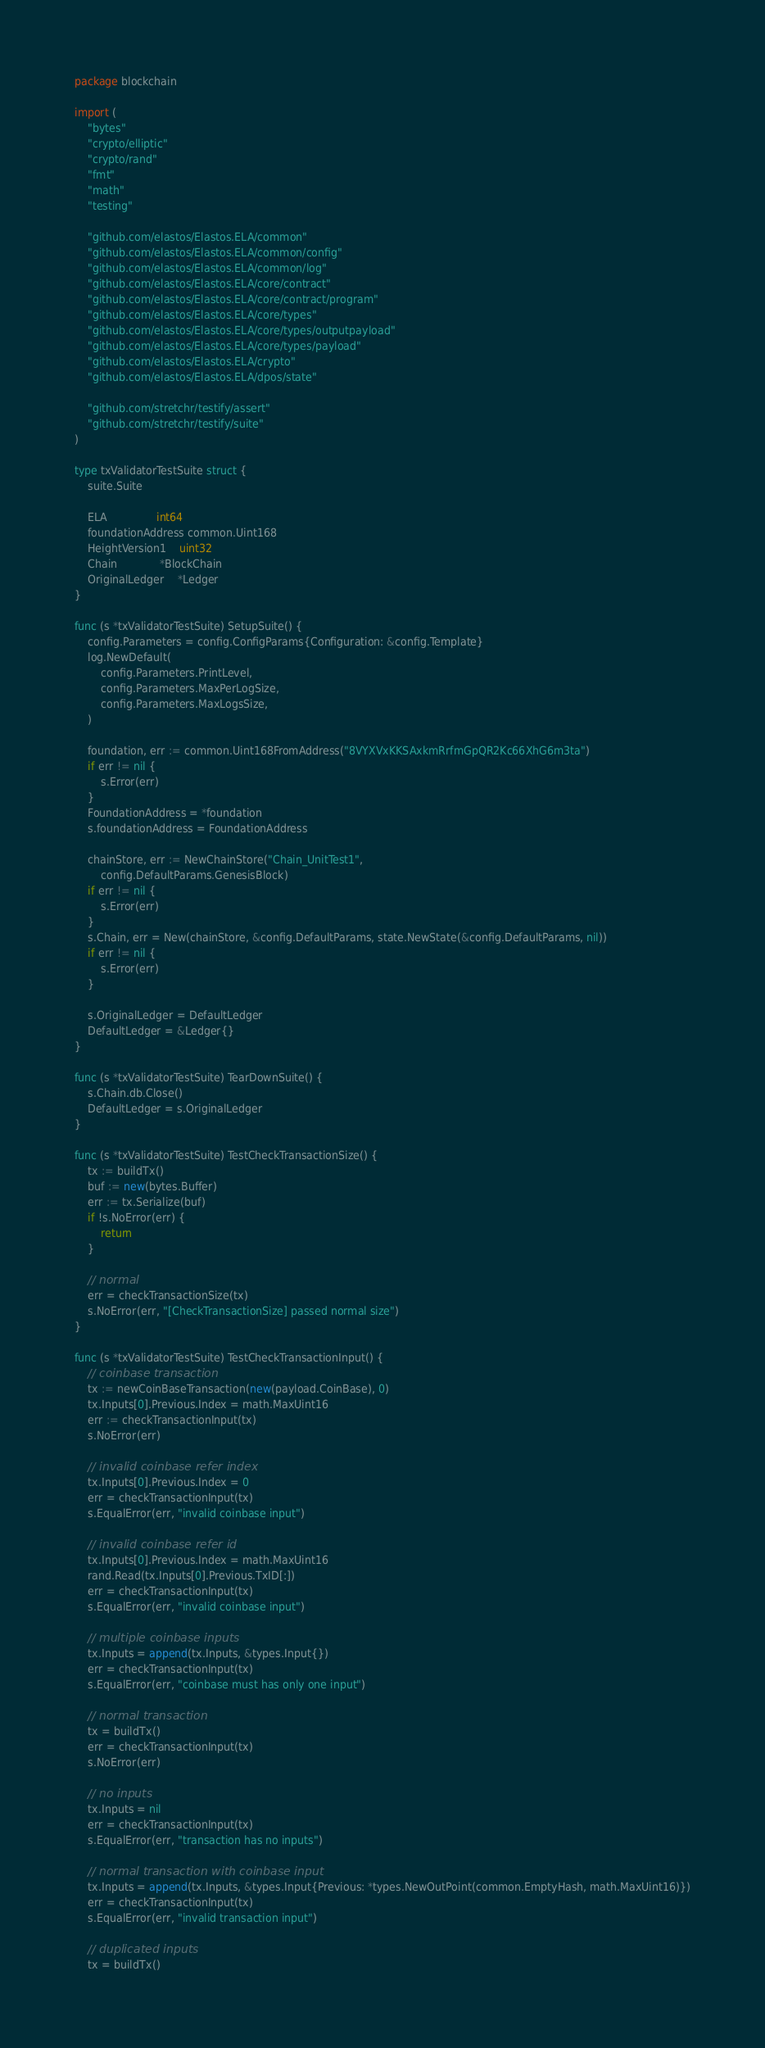Convert code to text. <code><loc_0><loc_0><loc_500><loc_500><_Go_>package blockchain

import (
	"bytes"
	"crypto/elliptic"
	"crypto/rand"
	"fmt"
	"math"
	"testing"

	"github.com/elastos/Elastos.ELA/common"
	"github.com/elastos/Elastos.ELA/common/config"
	"github.com/elastos/Elastos.ELA/common/log"
	"github.com/elastos/Elastos.ELA/core/contract"
	"github.com/elastos/Elastos.ELA/core/contract/program"
	"github.com/elastos/Elastos.ELA/core/types"
	"github.com/elastos/Elastos.ELA/core/types/outputpayload"
	"github.com/elastos/Elastos.ELA/core/types/payload"
	"github.com/elastos/Elastos.ELA/crypto"
	"github.com/elastos/Elastos.ELA/dpos/state"

	"github.com/stretchr/testify/assert"
	"github.com/stretchr/testify/suite"
)

type txValidatorTestSuite struct {
	suite.Suite

	ELA               int64
	foundationAddress common.Uint168
	HeightVersion1    uint32
	Chain             *BlockChain
	OriginalLedger    *Ledger
}

func (s *txValidatorTestSuite) SetupSuite() {
	config.Parameters = config.ConfigParams{Configuration: &config.Template}
	log.NewDefault(
		config.Parameters.PrintLevel,
		config.Parameters.MaxPerLogSize,
		config.Parameters.MaxLogsSize,
	)

	foundation, err := common.Uint168FromAddress("8VYXVxKKSAxkmRrfmGpQR2Kc66XhG6m3ta")
	if err != nil {
		s.Error(err)
	}
	FoundationAddress = *foundation
	s.foundationAddress = FoundationAddress

	chainStore, err := NewChainStore("Chain_UnitTest1",
		config.DefaultParams.GenesisBlock)
	if err != nil {
		s.Error(err)
	}
	s.Chain, err = New(chainStore, &config.DefaultParams, state.NewState(&config.DefaultParams, nil))
	if err != nil {
		s.Error(err)
	}

	s.OriginalLedger = DefaultLedger
	DefaultLedger = &Ledger{}
}

func (s *txValidatorTestSuite) TearDownSuite() {
	s.Chain.db.Close()
	DefaultLedger = s.OriginalLedger
}

func (s *txValidatorTestSuite) TestCheckTransactionSize() {
	tx := buildTx()
	buf := new(bytes.Buffer)
	err := tx.Serialize(buf)
	if !s.NoError(err) {
		return
	}

	// normal
	err = checkTransactionSize(tx)
	s.NoError(err, "[CheckTransactionSize] passed normal size")
}

func (s *txValidatorTestSuite) TestCheckTransactionInput() {
	// coinbase transaction
	tx := newCoinBaseTransaction(new(payload.CoinBase), 0)
	tx.Inputs[0].Previous.Index = math.MaxUint16
	err := checkTransactionInput(tx)
	s.NoError(err)

	// invalid coinbase refer index
	tx.Inputs[0].Previous.Index = 0
	err = checkTransactionInput(tx)
	s.EqualError(err, "invalid coinbase input")

	// invalid coinbase refer id
	tx.Inputs[0].Previous.Index = math.MaxUint16
	rand.Read(tx.Inputs[0].Previous.TxID[:])
	err = checkTransactionInput(tx)
	s.EqualError(err, "invalid coinbase input")

	// multiple coinbase inputs
	tx.Inputs = append(tx.Inputs, &types.Input{})
	err = checkTransactionInput(tx)
	s.EqualError(err, "coinbase must has only one input")

	// normal transaction
	tx = buildTx()
	err = checkTransactionInput(tx)
	s.NoError(err)

	// no inputs
	tx.Inputs = nil
	err = checkTransactionInput(tx)
	s.EqualError(err, "transaction has no inputs")

	// normal transaction with coinbase input
	tx.Inputs = append(tx.Inputs, &types.Input{Previous: *types.NewOutPoint(common.EmptyHash, math.MaxUint16)})
	err = checkTransactionInput(tx)
	s.EqualError(err, "invalid transaction input")

	// duplicated inputs
	tx = buildTx()</code> 